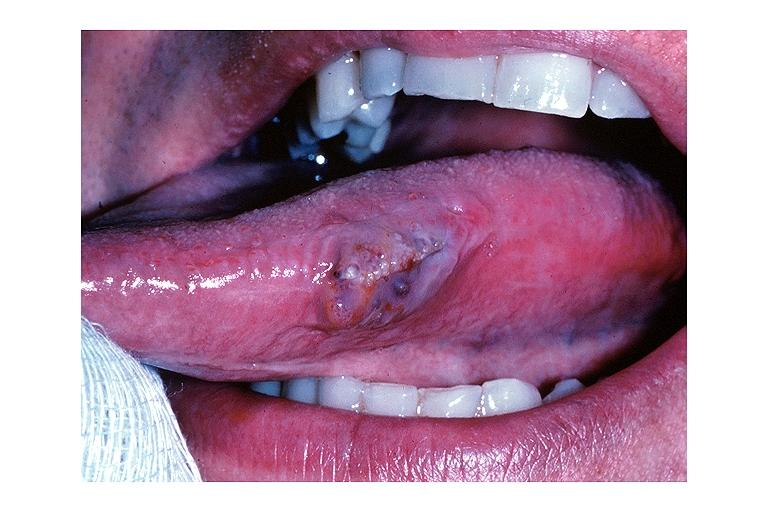what is present?
Answer the question using a single word or phrase. Oral 